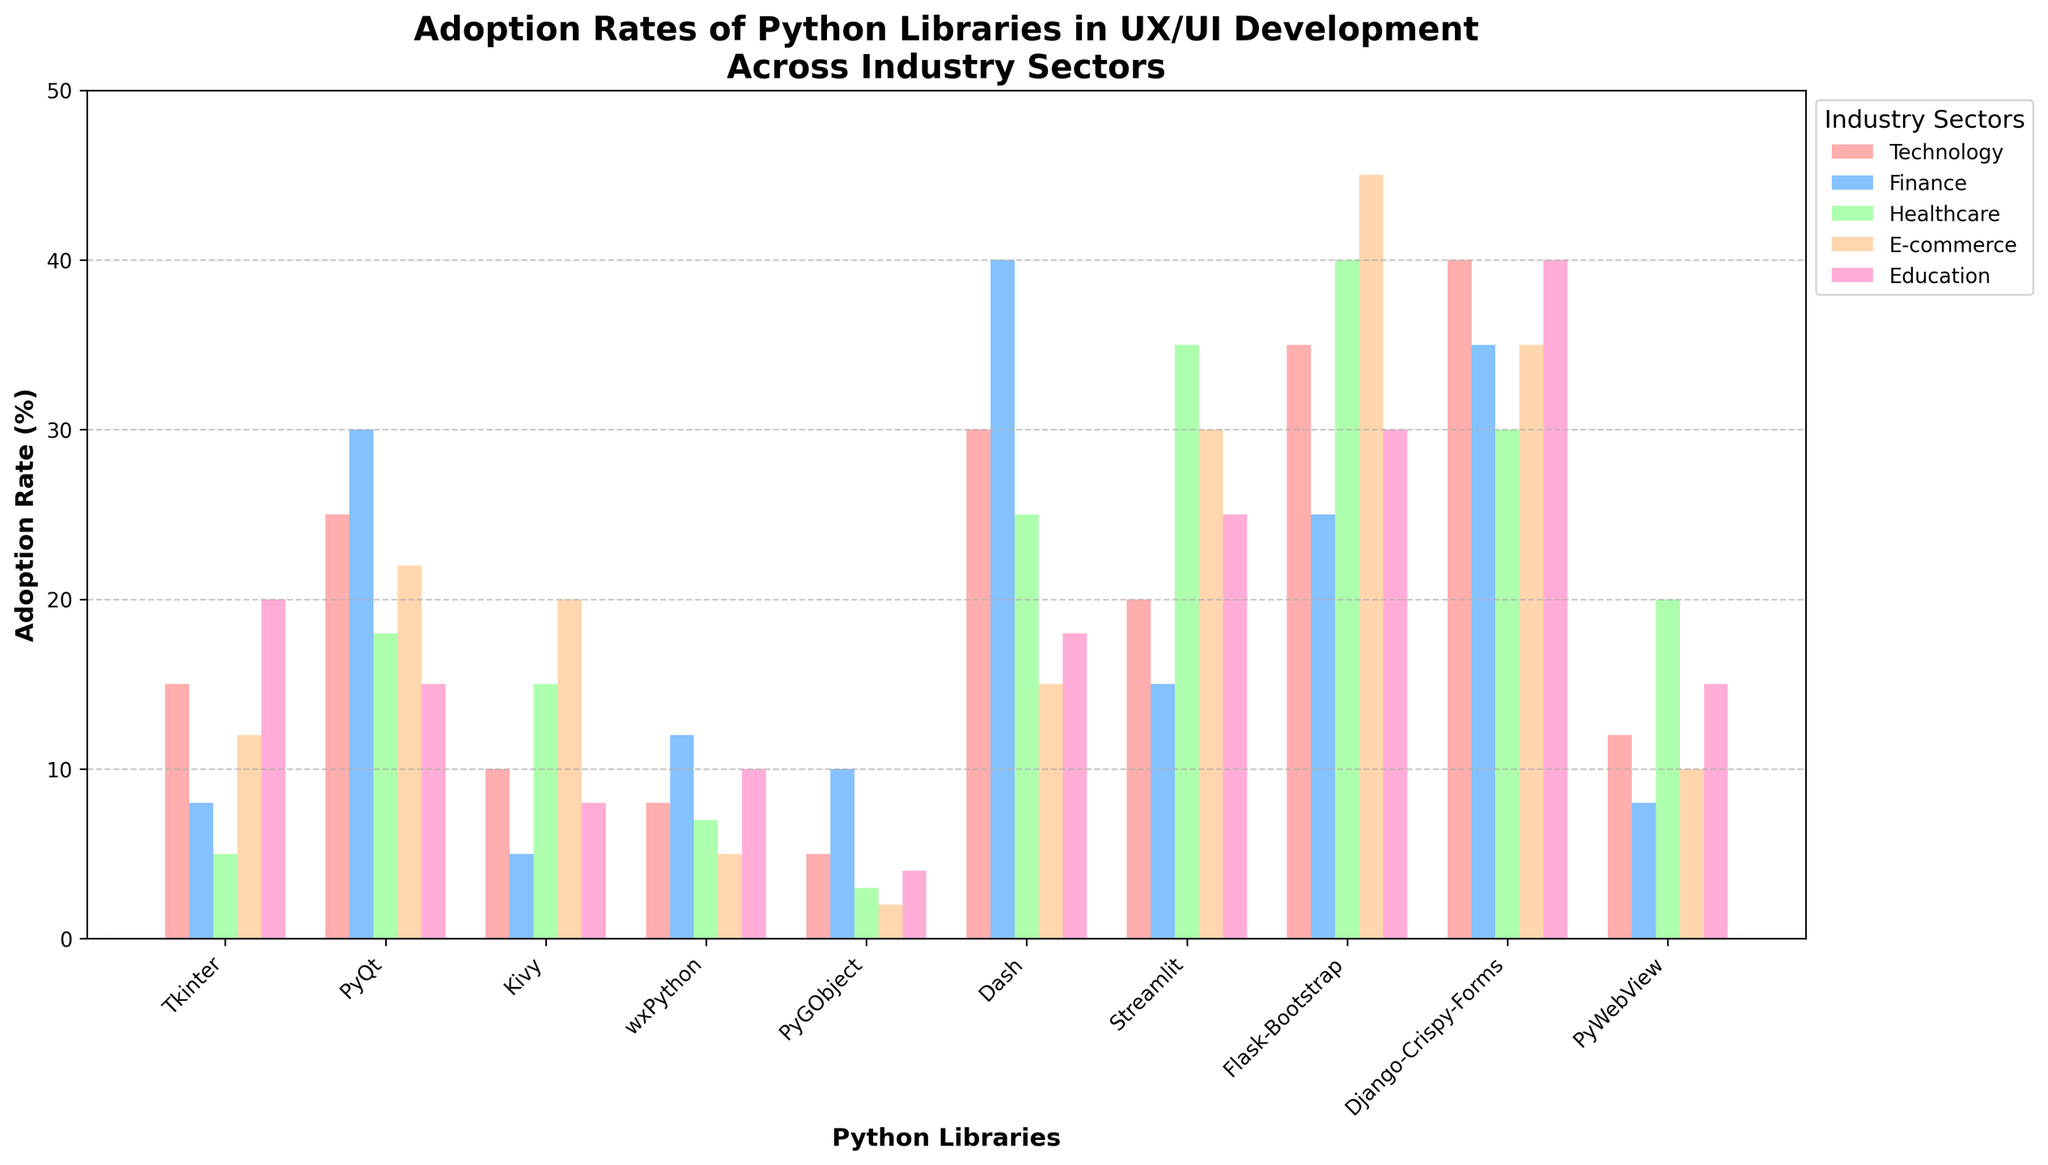What library has the highest adoption rate in the Technology sector? First, observe the colored bars corresponding to the Technology sector. Identify the tallest bar and its associated library label. The tallest bar in the Technology sector is for "Django-Crispy-Forms".
Answer: Django-Crispy-Forms Which sector has the lowest adoption rate for Kivy? Find the bars representing Kivy for each industry sector. The shortest bar is in the Finance sector, with a value of 5.
Answer: Finance What is the average adoption rate of Flask-Bootstrap across all sectors? Identify the heights of the bars for Flask-Bootstrap in all sectors: 35, 25, 40, 45, 30. Sum these values (35 + 25 + 40 + 45 + 30 = 175) and then divide by the number of sectors (175 / 5 = 35).
Answer: 35 Compare the adoption rates of PyQt and Dash in the Healthcare sector. Which one is higher? Observe the bars representing PyQt and Dash in the Healthcare sector. PyQt has an adoption rate of 18, while Dash has 25. Dash has a higher adoption rate.
Answer: Dash Which library has the smallest variance in adoption rates across the five industry sectors? Check the range of values for each library across all sectors. Calculate the variance (or range). PyGObject shows the smallest variance with adoption rates of 5, 10, 3, 2, 4.
Answer: PyGObject If the adoption rates in E-commerce and Education for Flask-Bootstrap suddenly dropped by 10 points, what would be its new average adoption rate across all sectors? Subtract 10 from the E-commerce (40) and Education (30) values for Flask-Bootstrap, resulting in new values of 30 and 20. Sum this with the unchanged values in Technology (35), Finance (25), and Healthcare (45) (35 + 25 + 45 + 30 + 20 = 155) and divide by 5 (155 / 5 = 31).
Answer: 31 What is the total adoption rate for Django-Crispy-Forms across all sectors? Sum the adoption rates of Django-Crispy-Forms in all sectors: 40, 35, 30, 35, 40 (40 + 35 + 30 + 35 + 40 = 180).
Answer: 180 Between Streamlit and PyWebView, which has the higher overall adoption rate in the Education sector? Compare the bar heights for Streamlit and PyWebView in the Education sector: Streamlit has 25, PyWebView has 15. Streamlit has the higher overall adoption rate.
Answer: Streamlit How does the adoption rate of Tkinter in Education compare to that of Dash in Technology? Find the heights of the respective bars: Tkinter in Education is 20, and Dash in Technology is 30. Dash in Technology has a higher adoption rate.
Answer: Dash in Technology 